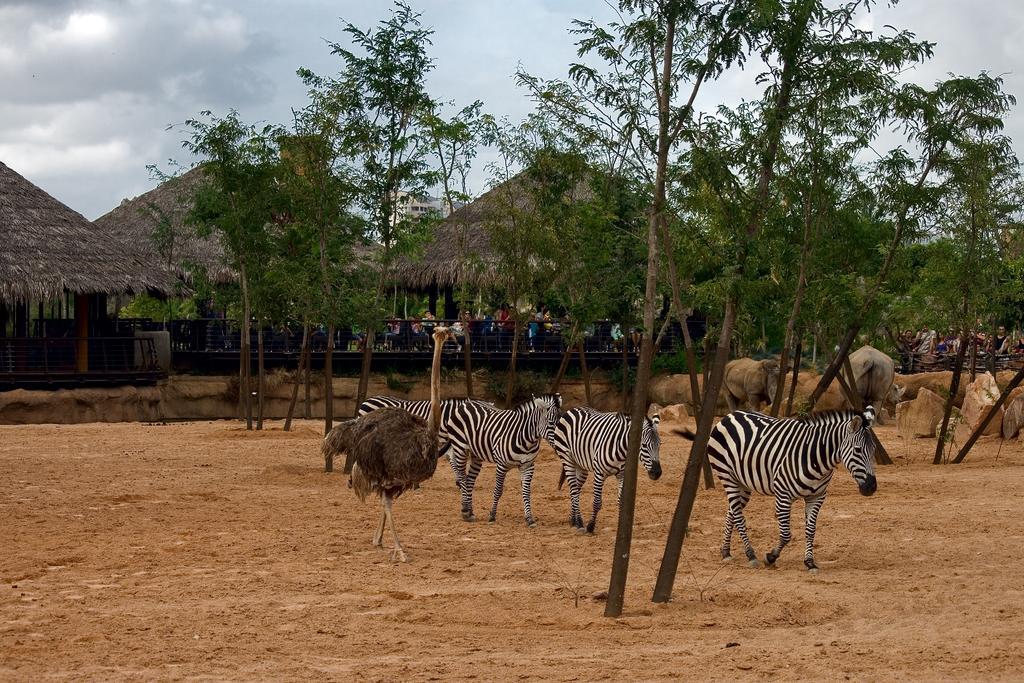Describe this image in one or two sentences. In this picture I can see ostrich on the surface. I can see animals on the surface. I can see trees. I can see rocks. I can see the huts in the background. I can see the metal grill fence. I can see a few people. I can see clouds in the sky. 